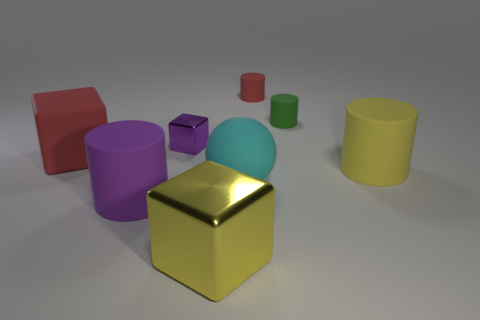Add 1 green matte cylinders. How many objects exist? 9 Subtract all balls. How many objects are left? 7 Subtract 1 purple cylinders. How many objects are left? 7 Subtract all small green things. Subtract all large green cylinders. How many objects are left? 7 Add 8 small cubes. How many small cubes are left? 9 Add 4 purple matte cylinders. How many purple matte cylinders exist? 5 